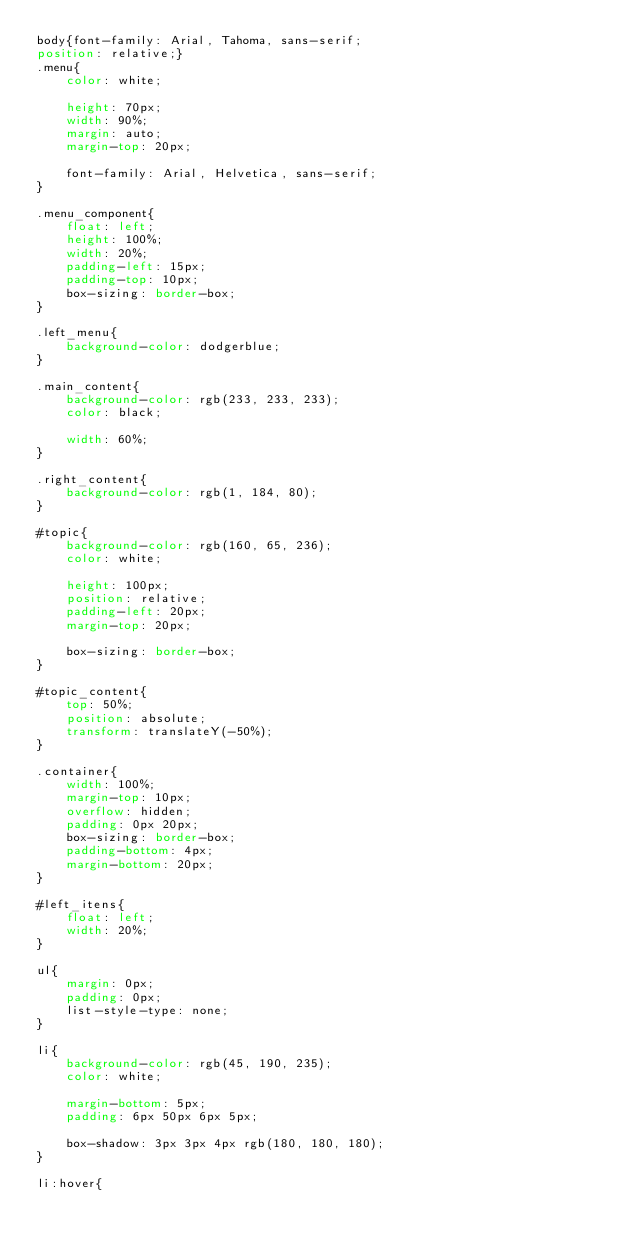<code> <loc_0><loc_0><loc_500><loc_500><_CSS_>body{font-family: Arial, Tahoma, sans-serif;
position: relative;}
.menu{
    color: white;

    height: 70px;
    width: 90%;
    margin: auto;
    margin-top: 20px;
    
    font-family: Arial, Helvetica, sans-serif;
}

.menu_component{
    float: left;
    height: 100%;
    width: 20%;
    padding-left: 15px;
    padding-top: 10px;
    box-sizing: border-box;
}

.left_menu{
    background-color: dodgerblue;
}

.main_content{
    background-color: rgb(233, 233, 233);
    color: black;

    width: 60%;
}

.right_content{
    background-color: rgb(1, 184, 80);
}

#topic{
    background-color: rgb(160, 65, 236);
    color: white;

    height: 100px;
    position: relative;
    padding-left: 20px;
    margin-top: 20px;

    box-sizing: border-box;
}

#topic_content{
    top: 50%;
    position: absolute;
    transform: translateY(-50%);
}

.container{
    width: 100%;
    margin-top: 10px;
    overflow: hidden;
    padding: 0px 20px;
    box-sizing: border-box;
    padding-bottom: 4px;
    margin-bottom: 20px;
}

#left_itens{
    float: left;
    width: 20%;
}

ul{
    margin: 0px;
    padding: 0px;
    list-style-type: none;
}

li{
    background-color: rgb(45, 190, 235);
    color: white;

    margin-bottom: 5px;
    padding: 6px 50px 6px 5px;

    box-shadow: 3px 3px 4px rgb(180, 180, 180);
}

li:hover{</code> 